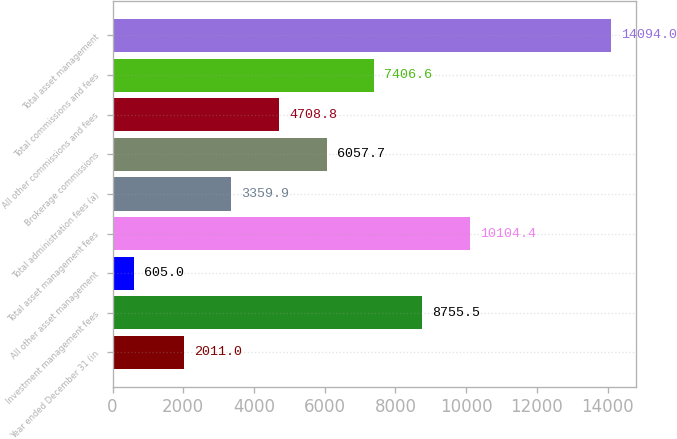Convert chart. <chart><loc_0><loc_0><loc_500><loc_500><bar_chart><fcel>Year ended December 31 (in<fcel>Investment management fees<fcel>All other asset management<fcel>Total asset management fees<fcel>Total administration fees (a)<fcel>Brokerage commissions<fcel>All other commissions and fees<fcel>Total commissions and fees<fcel>Total asset management<nl><fcel>2011<fcel>8755.5<fcel>605<fcel>10104.4<fcel>3359.9<fcel>6057.7<fcel>4708.8<fcel>7406.6<fcel>14094<nl></chart> 